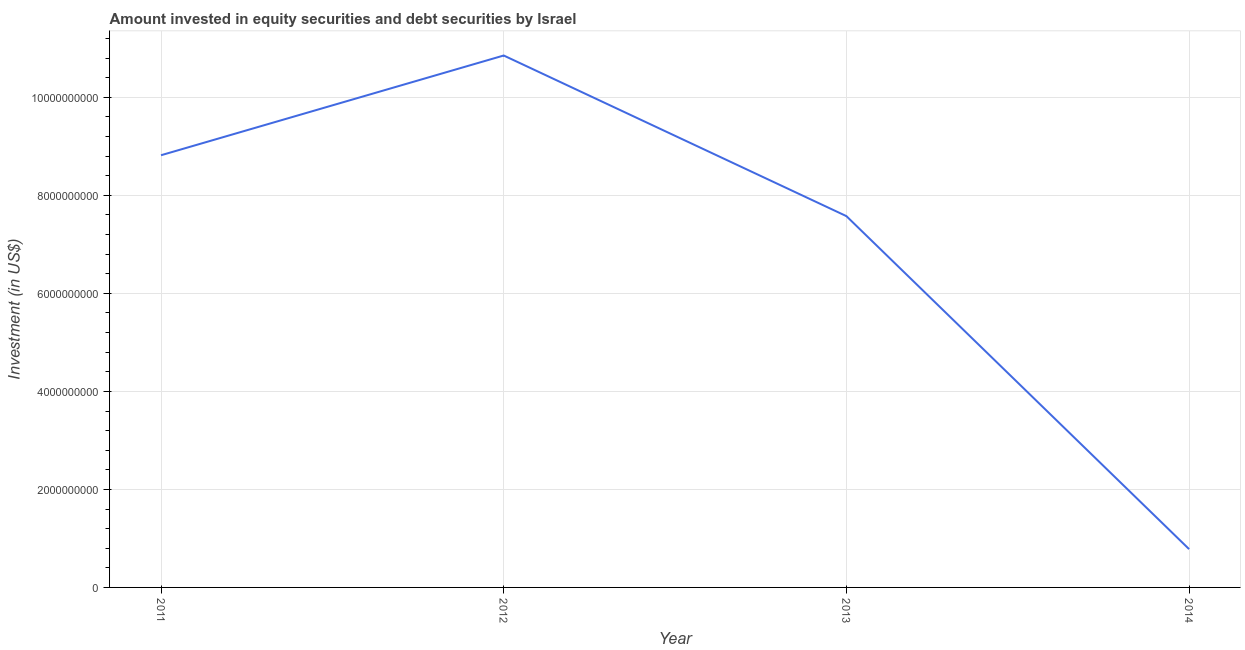What is the portfolio investment in 2013?
Provide a short and direct response. 7.58e+09. Across all years, what is the maximum portfolio investment?
Provide a succinct answer. 1.09e+1. Across all years, what is the minimum portfolio investment?
Ensure brevity in your answer.  7.82e+08. In which year was the portfolio investment minimum?
Provide a succinct answer. 2014. What is the sum of the portfolio investment?
Make the answer very short. 2.80e+1. What is the difference between the portfolio investment in 2011 and 2013?
Provide a succinct answer. 1.24e+09. What is the average portfolio investment per year?
Ensure brevity in your answer.  7.01e+09. What is the median portfolio investment?
Give a very brief answer. 8.20e+09. What is the ratio of the portfolio investment in 2012 to that in 2013?
Your answer should be compact. 1.43. Is the difference between the portfolio investment in 2011 and 2012 greater than the difference between any two years?
Offer a very short reply. No. What is the difference between the highest and the second highest portfolio investment?
Offer a terse response. 2.04e+09. What is the difference between the highest and the lowest portfolio investment?
Offer a terse response. 1.01e+1. Does the portfolio investment monotonically increase over the years?
Offer a terse response. No. How many lines are there?
Your response must be concise. 1. How many years are there in the graph?
Offer a very short reply. 4. Are the values on the major ticks of Y-axis written in scientific E-notation?
Your response must be concise. No. Does the graph contain grids?
Offer a very short reply. Yes. What is the title of the graph?
Offer a terse response. Amount invested in equity securities and debt securities by Israel. What is the label or title of the X-axis?
Your response must be concise. Year. What is the label or title of the Y-axis?
Make the answer very short. Investment (in US$). What is the Investment (in US$) of 2011?
Offer a terse response. 8.82e+09. What is the Investment (in US$) in 2012?
Give a very brief answer. 1.09e+1. What is the Investment (in US$) of 2013?
Provide a succinct answer. 7.58e+09. What is the Investment (in US$) in 2014?
Your answer should be very brief. 7.82e+08. What is the difference between the Investment (in US$) in 2011 and 2012?
Offer a terse response. -2.04e+09. What is the difference between the Investment (in US$) in 2011 and 2013?
Provide a succinct answer. 1.24e+09. What is the difference between the Investment (in US$) in 2011 and 2014?
Provide a succinct answer. 8.04e+09. What is the difference between the Investment (in US$) in 2012 and 2013?
Offer a very short reply. 3.28e+09. What is the difference between the Investment (in US$) in 2012 and 2014?
Your answer should be very brief. 1.01e+1. What is the difference between the Investment (in US$) in 2013 and 2014?
Your answer should be very brief. 6.80e+09. What is the ratio of the Investment (in US$) in 2011 to that in 2012?
Keep it short and to the point. 0.81. What is the ratio of the Investment (in US$) in 2011 to that in 2013?
Your answer should be compact. 1.16. What is the ratio of the Investment (in US$) in 2011 to that in 2014?
Make the answer very short. 11.28. What is the ratio of the Investment (in US$) in 2012 to that in 2013?
Offer a very short reply. 1.43. What is the ratio of the Investment (in US$) in 2012 to that in 2014?
Give a very brief answer. 13.89. What is the ratio of the Investment (in US$) in 2013 to that in 2014?
Your answer should be very brief. 9.69. 